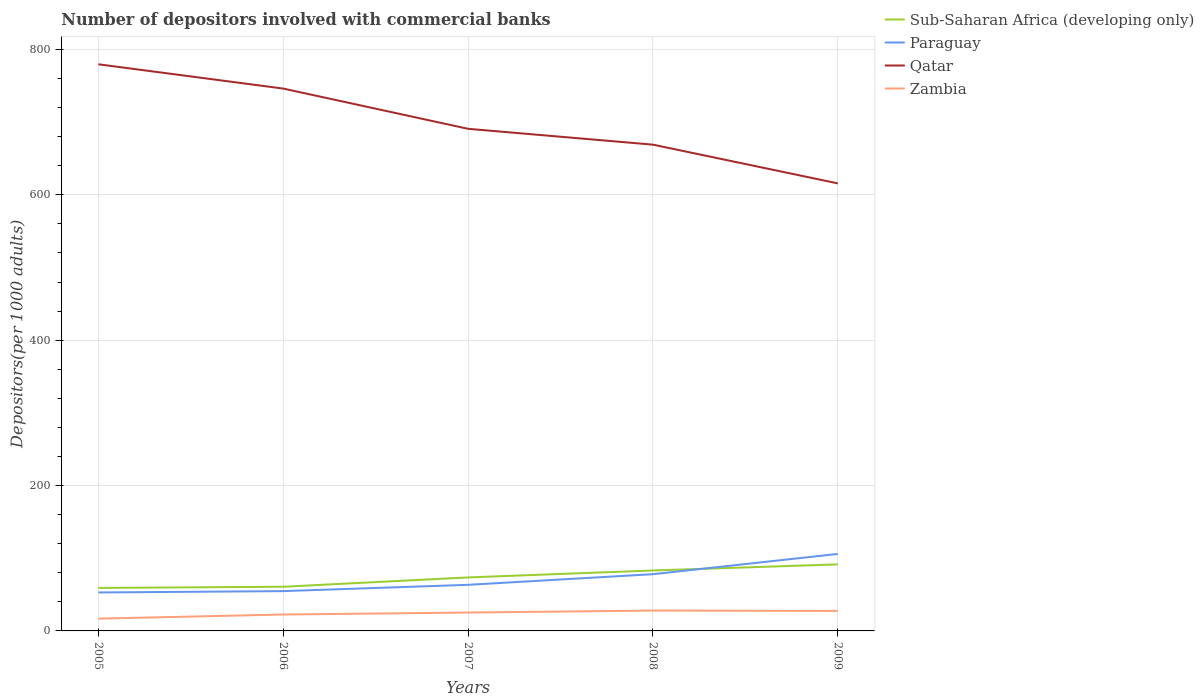How many different coloured lines are there?
Provide a short and direct response. 4. Does the line corresponding to Paraguay intersect with the line corresponding to Sub-Saharan Africa (developing only)?
Provide a succinct answer. Yes. Is the number of lines equal to the number of legend labels?
Give a very brief answer. Yes. Across all years, what is the maximum number of depositors involved with commercial banks in Zambia?
Your answer should be very brief. 16.89. What is the total number of depositors involved with commercial banks in Sub-Saharan Africa (developing only) in the graph?
Offer a very short reply. -32.38. What is the difference between the highest and the second highest number of depositors involved with commercial banks in Sub-Saharan Africa (developing only)?
Your response must be concise. 32.38. How many years are there in the graph?
Your answer should be compact. 5. What is the difference between two consecutive major ticks on the Y-axis?
Provide a succinct answer. 200. Are the values on the major ticks of Y-axis written in scientific E-notation?
Provide a succinct answer. No. Does the graph contain grids?
Your answer should be very brief. Yes. Where does the legend appear in the graph?
Your response must be concise. Top right. How are the legend labels stacked?
Your answer should be compact. Vertical. What is the title of the graph?
Make the answer very short. Number of depositors involved with commercial banks. Does "Antigua and Barbuda" appear as one of the legend labels in the graph?
Give a very brief answer. No. What is the label or title of the Y-axis?
Your answer should be very brief. Depositors(per 1000 adults). What is the Depositors(per 1000 adults) in Sub-Saharan Africa (developing only) in 2005?
Your response must be concise. 59.17. What is the Depositors(per 1000 adults) of Paraguay in 2005?
Make the answer very short. 52.9. What is the Depositors(per 1000 adults) in Qatar in 2005?
Make the answer very short. 779.56. What is the Depositors(per 1000 adults) of Zambia in 2005?
Provide a short and direct response. 16.89. What is the Depositors(per 1000 adults) in Sub-Saharan Africa (developing only) in 2006?
Provide a succinct answer. 60.76. What is the Depositors(per 1000 adults) of Paraguay in 2006?
Provide a short and direct response. 54.74. What is the Depositors(per 1000 adults) in Qatar in 2006?
Make the answer very short. 746.16. What is the Depositors(per 1000 adults) in Zambia in 2006?
Your answer should be very brief. 22.58. What is the Depositors(per 1000 adults) in Sub-Saharan Africa (developing only) in 2007?
Ensure brevity in your answer.  73.6. What is the Depositors(per 1000 adults) of Paraguay in 2007?
Offer a very short reply. 63.43. What is the Depositors(per 1000 adults) of Qatar in 2007?
Your response must be concise. 690.79. What is the Depositors(per 1000 adults) of Zambia in 2007?
Keep it short and to the point. 25.28. What is the Depositors(per 1000 adults) in Sub-Saharan Africa (developing only) in 2008?
Your response must be concise. 83.18. What is the Depositors(per 1000 adults) in Paraguay in 2008?
Keep it short and to the point. 78.05. What is the Depositors(per 1000 adults) of Qatar in 2008?
Offer a very short reply. 668.99. What is the Depositors(per 1000 adults) in Zambia in 2008?
Make the answer very short. 28.01. What is the Depositors(per 1000 adults) in Sub-Saharan Africa (developing only) in 2009?
Give a very brief answer. 91.54. What is the Depositors(per 1000 adults) of Paraguay in 2009?
Offer a terse response. 105.92. What is the Depositors(per 1000 adults) in Qatar in 2009?
Provide a succinct answer. 615.73. What is the Depositors(per 1000 adults) in Zambia in 2009?
Provide a succinct answer. 27.51. Across all years, what is the maximum Depositors(per 1000 adults) in Sub-Saharan Africa (developing only)?
Offer a terse response. 91.54. Across all years, what is the maximum Depositors(per 1000 adults) in Paraguay?
Provide a succinct answer. 105.92. Across all years, what is the maximum Depositors(per 1000 adults) in Qatar?
Keep it short and to the point. 779.56. Across all years, what is the maximum Depositors(per 1000 adults) in Zambia?
Give a very brief answer. 28.01. Across all years, what is the minimum Depositors(per 1000 adults) in Sub-Saharan Africa (developing only)?
Give a very brief answer. 59.17. Across all years, what is the minimum Depositors(per 1000 adults) in Paraguay?
Your answer should be very brief. 52.9. Across all years, what is the minimum Depositors(per 1000 adults) in Qatar?
Make the answer very short. 615.73. Across all years, what is the minimum Depositors(per 1000 adults) of Zambia?
Offer a terse response. 16.89. What is the total Depositors(per 1000 adults) of Sub-Saharan Africa (developing only) in the graph?
Provide a succinct answer. 368.25. What is the total Depositors(per 1000 adults) in Paraguay in the graph?
Your answer should be very brief. 355.04. What is the total Depositors(per 1000 adults) in Qatar in the graph?
Keep it short and to the point. 3501.23. What is the total Depositors(per 1000 adults) of Zambia in the graph?
Give a very brief answer. 120.26. What is the difference between the Depositors(per 1000 adults) of Sub-Saharan Africa (developing only) in 2005 and that in 2006?
Provide a succinct answer. -1.59. What is the difference between the Depositors(per 1000 adults) in Paraguay in 2005 and that in 2006?
Your answer should be compact. -1.85. What is the difference between the Depositors(per 1000 adults) of Qatar in 2005 and that in 2006?
Keep it short and to the point. 33.4. What is the difference between the Depositors(per 1000 adults) in Zambia in 2005 and that in 2006?
Provide a short and direct response. -5.68. What is the difference between the Depositors(per 1000 adults) in Sub-Saharan Africa (developing only) in 2005 and that in 2007?
Keep it short and to the point. -14.43. What is the difference between the Depositors(per 1000 adults) of Paraguay in 2005 and that in 2007?
Offer a terse response. -10.54. What is the difference between the Depositors(per 1000 adults) in Qatar in 2005 and that in 2007?
Your answer should be compact. 88.76. What is the difference between the Depositors(per 1000 adults) of Zambia in 2005 and that in 2007?
Your answer should be compact. -8.38. What is the difference between the Depositors(per 1000 adults) in Sub-Saharan Africa (developing only) in 2005 and that in 2008?
Provide a short and direct response. -24.01. What is the difference between the Depositors(per 1000 adults) of Paraguay in 2005 and that in 2008?
Provide a short and direct response. -25.15. What is the difference between the Depositors(per 1000 adults) in Qatar in 2005 and that in 2008?
Offer a terse response. 110.57. What is the difference between the Depositors(per 1000 adults) of Zambia in 2005 and that in 2008?
Make the answer very short. -11.11. What is the difference between the Depositors(per 1000 adults) in Sub-Saharan Africa (developing only) in 2005 and that in 2009?
Keep it short and to the point. -32.38. What is the difference between the Depositors(per 1000 adults) in Paraguay in 2005 and that in 2009?
Your answer should be very brief. -53.02. What is the difference between the Depositors(per 1000 adults) in Qatar in 2005 and that in 2009?
Provide a succinct answer. 163.83. What is the difference between the Depositors(per 1000 adults) of Zambia in 2005 and that in 2009?
Offer a terse response. -10.61. What is the difference between the Depositors(per 1000 adults) in Sub-Saharan Africa (developing only) in 2006 and that in 2007?
Your answer should be compact. -12.83. What is the difference between the Depositors(per 1000 adults) in Paraguay in 2006 and that in 2007?
Make the answer very short. -8.69. What is the difference between the Depositors(per 1000 adults) in Qatar in 2006 and that in 2007?
Ensure brevity in your answer.  55.37. What is the difference between the Depositors(per 1000 adults) in Zambia in 2006 and that in 2007?
Provide a succinct answer. -2.7. What is the difference between the Depositors(per 1000 adults) of Sub-Saharan Africa (developing only) in 2006 and that in 2008?
Provide a succinct answer. -22.41. What is the difference between the Depositors(per 1000 adults) of Paraguay in 2006 and that in 2008?
Keep it short and to the point. -23.31. What is the difference between the Depositors(per 1000 adults) of Qatar in 2006 and that in 2008?
Your answer should be compact. 77.17. What is the difference between the Depositors(per 1000 adults) of Zambia in 2006 and that in 2008?
Your answer should be compact. -5.43. What is the difference between the Depositors(per 1000 adults) in Sub-Saharan Africa (developing only) in 2006 and that in 2009?
Provide a succinct answer. -30.78. What is the difference between the Depositors(per 1000 adults) of Paraguay in 2006 and that in 2009?
Your response must be concise. -51.17. What is the difference between the Depositors(per 1000 adults) in Qatar in 2006 and that in 2009?
Provide a succinct answer. 130.43. What is the difference between the Depositors(per 1000 adults) of Zambia in 2006 and that in 2009?
Your answer should be very brief. -4.93. What is the difference between the Depositors(per 1000 adults) of Sub-Saharan Africa (developing only) in 2007 and that in 2008?
Provide a short and direct response. -9.58. What is the difference between the Depositors(per 1000 adults) in Paraguay in 2007 and that in 2008?
Provide a short and direct response. -14.62. What is the difference between the Depositors(per 1000 adults) in Qatar in 2007 and that in 2008?
Ensure brevity in your answer.  21.8. What is the difference between the Depositors(per 1000 adults) of Zambia in 2007 and that in 2008?
Give a very brief answer. -2.73. What is the difference between the Depositors(per 1000 adults) of Sub-Saharan Africa (developing only) in 2007 and that in 2009?
Give a very brief answer. -17.95. What is the difference between the Depositors(per 1000 adults) of Paraguay in 2007 and that in 2009?
Your response must be concise. -42.48. What is the difference between the Depositors(per 1000 adults) in Qatar in 2007 and that in 2009?
Provide a short and direct response. 75.07. What is the difference between the Depositors(per 1000 adults) of Zambia in 2007 and that in 2009?
Offer a very short reply. -2.23. What is the difference between the Depositors(per 1000 adults) in Sub-Saharan Africa (developing only) in 2008 and that in 2009?
Offer a terse response. -8.37. What is the difference between the Depositors(per 1000 adults) of Paraguay in 2008 and that in 2009?
Provide a short and direct response. -27.87. What is the difference between the Depositors(per 1000 adults) of Qatar in 2008 and that in 2009?
Ensure brevity in your answer.  53.27. What is the difference between the Depositors(per 1000 adults) in Zambia in 2008 and that in 2009?
Provide a short and direct response. 0.5. What is the difference between the Depositors(per 1000 adults) of Sub-Saharan Africa (developing only) in 2005 and the Depositors(per 1000 adults) of Paraguay in 2006?
Ensure brevity in your answer.  4.42. What is the difference between the Depositors(per 1000 adults) in Sub-Saharan Africa (developing only) in 2005 and the Depositors(per 1000 adults) in Qatar in 2006?
Offer a terse response. -686.99. What is the difference between the Depositors(per 1000 adults) in Sub-Saharan Africa (developing only) in 2005 and the Depositors(per 1000 adults) in Zambia in 2006?
Ensure brevity in your answer.  36.59. What is the difference between the Depositors(per 1000 adults) of Paraguay in 2005 and the Depositors(per 1000 adults) of Qatar in 2006?
Your answer should be very brief. -693.26. What is the difference between the Depositors(per 1000 adults) in Paraguay in 2005 and the Depositors(per 1000 adults) in Zambia in 2006?
Provide a short and direct response. 30.32. What is the difference between the Depositors(per 1000 adults) of Qatar in 2005 and the Depositors(per 1000 adults) of Zambia in 2006?
Offer a terse response. 756.98. What is the difference between the Depositors(per 1000 adults) in Sub-Saharan Africa (developing only) in 2005 and the Depositors(per 1000 adults) in Paraguay in 2007?
Make the answer very short. -4.27. What is the difference between the Depositors(per 1000 adults) in Sub-Saharan Africa (developing only) in 2005 and the Depositors(per 1000 adults) in Qatar in 2007?
Offer a very short reply. -631.63. What is the difference between the Depositors(per 1000 adults) in Sub-Saharan Africa (developing only) in 2005 and the Depositors(per 1000 adults) in Zambia in 2007?
Your answer should be very brief. 33.89. What is the difference between the Depositors(per 1000 adults) of Paraguay in 2005 and the Depositors(per 1000 adults) of Qatar in 2007?
Your response must be concise. -637.9. What is the difference between the Depositors(per 1000 adults) in Paraguay in 2005 and the Depositors(per 1000 adults) in Zambia in 2007?
Ensure brevity in your answer.  27.62. What is the difference between the Depositors(per 1000 adults) in Qatar in 2005 and the Depositors(per 1000 adults) in Zambia in 2007?
Give a very brief answer. 754.28. What is the difference between the Depositors(per 1000 adults) of Sub-Saharan Africa (developing only) in 2005 and the Depositors(per 1000 adults) of Paraguay in 2008?
Make the answer very short. -18.88. What is the difference between the Depositors(per 1000 adults) of Sub-Saharan Africa (developing only) in 2005 and the Depositors(per 1000 adults) of Qatar in 2008?
Provide a succinct answer. -609.82. What is the difference between the Depositors(per 1000 adults) of Sub-Saharan Africa (developing only) in 2005 and the Depositors(per 1000 adults) of Zambia in 2008?
Offer a terse response. 31.16. What is the difference between the Depositors(per 1000 adults) in Paraguay in 2005 and the Depositors(per 1000 adults) in Qatar in 2008?
Ensure brevity in your answer.  -616.1. What is the difference between the Depositors(per 1000 adults) in Paraguay in 2005 and the Depositors(per 1000 adults) in Zambia in 2008?
Your answer should be compact. 24.89. What is the difference between the Depositors(per 1000 adults) in Qatar in 2005 and the Depositors(per 1000 adults) in Zambia in 2008?
Provide a succinct answer. 751.55. What is the difference between the Depositors(per 1000 adults) of Sub-Saharan Africa (developing only) in 2005 and the Depositors(per 1000 adults) of Paraguay in 2009?
Give a very brief answer. -46.75. What is the difference between the Depositors(per 1000 adults) in Sub-Saharan Africa (developing only) in 2005 and the Depositors(per 1000 adults) in Qatar in 2009?
Provide a short and direct response. -556.56. What is the difference between the Depositors(per 1000 adults) in Sub-Saharan Africa (developing only) in 2005 and the Depositors(per 1000 adults) in Zambia in 2009?
Offer a terse response. 31.66. What is the difference between the Depositors(per 1000 adults) of Paraguay in 2005 and the Depositors(per 1000 adults) of Qatar in 2009?
Ensure brevity in your answer.  -562.83. What is the difference between the Depositors(per 1000 adults) of Paraguay in 2005 and the Depositors(per 1000 adults) of Zambia in 2009?
Provide a succinct answer. 25.39. What is the difference between the Depositors(per 1000 adults) of Qatar in 2005 and the Depositors(per 1000 adults) of Zambia in 2009?
Make the answer very short. 752.05. What is the difference between the Depositors(per 1000 adults) of Sub-Saharan Africa (developing only) in 2006 and the Depositors(per 1000 adults) of Paraguay in 2007?
Your response must be concise. -2.67. What is the difference between the Depositors(per 1000 adults) in Sub-Saharan Africa (developing only) in 2006 and the Depositors(per 1000 adults) in Qatar in 2007?
Offer a terse response. -630.03. What is the difference between the Depositors(per 1000 adults) in Sub-Saharan Africa (developing only) in 2006 and the Depositors(per 1000 adults) in Zambia in 2007?
Offer a very short reply. 35.49. What is the difference between the Depositors(per 1000 adults) in Paraguay in 2006 and the Depositors(per 1000 adults) in Qatar in 2007?
Provide a short and direct response. -636.05. What is the difference between the Depositors(per 1000 adults) in Paraguay in 2006 and the Depositors(per 1000 adults) in Zambia in 2007?
Make the answer very short. 29.47. What is the difference between the Depositors(per 1000 adults) of Qatar in 2006 and the Depositors(per 1000 adults) of Zambia in 2007?
Make the answer very short. 720.88. What is the difference between the Depositors(per 1000 adults) of Sub-Saharan Africa (developing only) in 2006 and the Depositors(per 1000 adults) of Paraguay in 2008?
Provide a succinct answer. -17.29. What is the difference between the Depositors(per 1000 adults) of Sub-Saharan Africa (developing only) in 2006 and the Depositors(per 1000 adults) of Qatar in 2008?
Offer a terse response. -608.23. What is the difference between the Depositors(per 1000 adults) in Sub-Saharan Africa (developing only) in 2006 and the Depositors(per 1000 adults) in Zambia in 2008?
Make the answer very short. 32.76. What is the difference between the Depositors(per 1000 adults) in Paraguay in 2006 and the Depositors(per 1000 adults) in Qatar in 2008?
Your answer should be compact. -614.25. What is the difference between the Depositors(per 1000 adults) of Paraguay in 2006 and the Depositors(per 1000 adults) of Zambia in 2008?
Offer a terse response. 26.74. What is the difference between the Depositors(per 1000 adults) in Qatar in 2006 and the Depositors(per 1000 adults) in Zambia in 2008?
Ensure brevity in your answer.  718.16. What is the difference between the Depositors(per 1000 adults) in Sub-Saharan Africa (developing only) in 2006 and the Depositors(per 1000 adults) in Paraguay in 2009?
Give a very brief answer. -45.15. What is the difference between the Depositors(per 1000 adults) of Sub-Saharan Africa (developing only) in 2006 and the Depositors(per 1000 adults) of Qatar in 2009?
Offer a very short reply. -554.96. What is the difference between the Depositors(per 1000 adults) of Sub-Saharan Africa (developing only) in 2006 and the Depositors(per 1000 adults) of Zambia in 2009?
Keep it short and to the point. 33.25. What is the difference between the Depositors(per 1000 adults) of Paraguay in 2006 and the Depositors(per 1000 adults) of Qatar in 2009?
Offer a terse response. -560.98. What is the difference between the Depositors(per 1000 adults) in Paraguay in 2006 and the Depositors(per 1000 adults) in Zambia in 2009?
Your answer should be very brief. 27.24. What is the difference between the Depositors(per 1000 adults) in Qatar in 2006 and the Depositors(per 1000 adults) in Zambia in 2009?
Provide a succinct answer. 718.65. What is the difference between the Depositors(per 1000 adults) in Sub-Saharan Africa (developing only) in 2007 and the Depositors(per 1000 adults) in Paraguay in 2008?
Provide a short and direct response. -4.45. What is the difference between the Depositors(per 1000 adults) of Sub-Saharan Africa (developing only) in 2007 and the Depositors(per 1000 adults) of Qatar in 2008?
Ensure brevity in your answer.  -595.39. What is the difference between the Depositors(per 1000 adults) in Sub-Saharan Africa (developing only) in 2007 and the Depositors(per 1000 adults) in Zambia in 2008?
Your answer should be compact. 45.59. What is the difference between the Depositors(per 1000 adults) of Paraguay in 2007 and the Depositors(per 1000 adults) of Qatar in 2008?
Offer a terse response. -605.56. What is the difference between the Depositors(per 1000 adults) in Paraguay in 2007 and the Depositors(per 1000 adults) in Zambia in 2008?
Provide a short and direct response. 35.43. What is the difference between the Depositors(per 1000 adults) in Qatar in 2007 and the Depositors(per 1000 adults) in Zambia in 2008?
Offer a terse response. 662.79. What is the difference between the Depositors(per 1000 adults) of Sub-Saharan Africa (developing only) in 2007 and the Depositors(per 1000 adults) of Paraguay in 2009?
Your answer should be compact. -32.32. What is the difference between the Depositors(per 1000 adults) of Sub-Saharan Africa (developing only) in 2007 and the Depositors(per 1000 adults) of Qatar in 2009?
Offer a very short reply. -542.13. What is the difference between the Depositors(per 1000 adults) of Sub-Saharan Africa (developing only) in 2007 and the Depositors(per 1000 adults) of Zambia in 2009?
Keep it short and to the point. 46.09. What is the difference between the Depositors(per 1000 adults) in Paraguay in 2007 and the Depositors(per 1000 adults) in Qatar in 2009?
Your answer should be compact. -552.29. What is the difference between the Depositors(per 1000 adults) in Paraguay in 2007 and the Depositors(per 1000 adults) in Zambia in 2009?
Offer a very short reply. 35.93. What is the difference between the Depositors(per 1000 adults) in Qatar in 2007 and the Depositors(per 1000 adults) in Zambia in 2009?
Ensure brevity in your answer.  663.29. What is the difference between the Depositors(per 1000 adults) of Sub-Saharan Africa (developing only) in 2008 and the Depositors(per 1000 adults) of Paraguay in 2009?
Keep it short and to the point. -22.74. What is the difference between the Depositors(per 1000 adults) in Sub-Saharan Africa (developing only) in 2008 and the Depositors(per 1000 adults) in Qatar in 2009?
Provide a succinct answer. -532.55. What is the difference between the Depositors(per 1000 adults) of Sub-Saharan Africa (developing only) in 2008 and the Depositors(per 1000 adults) of Zambia in 2009?
Your answer should be very brief. 55.67. What is the difference between the Depositors(per 1000 adults) in Paraguay in 2008 and the Depositors(per 1000 adults) in Qatar in 2009?
Provide a succinct answer. -537.68. What is the difference between the Depositors(per 1000 adults) in Paraguay in 2008 and the Depositors(per 1000 adults) in Zambia in 2009?
Provide a short and direct response. 50.54. What is the difference between the Depositors(per 1000 adults) in Qatar in 2008 and the Depositors(per 1000 adults) in Zambia in 2009?
Keep it short and to the point. 641.48. What is the average Depositors(per 1000 adults) in Sub-Saharan Africa (developing only) per year?
Your response must be concise. 73.65. What is the average Depositors(per 1000 adults) in Paraguay per year?
Offer a very short reply. 71.01. What is the average Depositors(per 1000 adults) in Qatar per year?
Provide a succinct answer. 700.25. What is the average Depositors(per 1000 adults) of Zambia per year?
Ensure brevity in your answer.  24.05. In the year 2005, what is the difference between the Depositors(per 1000 adults) in Sub-Saharan Africa (developing only) and Depositors(per 1000 adults) in Paraguay?
Your answer should be very brief. 6.27. In the year 2005, what is the difference between the Depositors(per 1000 adults) in Sub-Saharan Africa (developing only) and Depositors(per 1000 adults) in Qatar?
Provide a short and direct response. -720.39. In the year 2005, what is the difference between the Depositors(per 1000 adults) of Sub-Saharan Africa (developing only) and Depositors(per 1000 adults) of Zambia?
Your answer should be compact. 42.27. In the year 2005, what is the difference between the Depositors(per 1000 adults) of Paraguay and Depositors(per 1000 adults) of Qatar?
Offer a very short reply. -726.66. In the year 2005, what is the difference between the Depositors(per 1000 adults) in Paraguay and Depositors(per 1000 adults) in Zambia?
Make the answer very short. 36. In the year 2005, what is the difference between the Depositors(per 1000 adults) of Qatar and Depositors(per 1000 adults) of Zambia?
Your answer should be very brief. 762.66. In the year 2006, what is the difference between the Depositors(per 1000 adults) of Sub-Saharan Africa (developing only) and Depositors(per 1000 adults) of Paraguay?
Provide a short and direct response. 6.02. In the year 2006, what is the difference between the Depositors(per 1000 adults) of Sub-Saharan Africa (developing only) and Depositors(per 1000 adults) of Qatar?
Ensure brevity in your answer.  -685.4. In the year 2006, what is the difference between the Depositors(per 1000 adults) of Sub-Saharan Africa (developing only) and Depositors(per 1000 adults) of Zambia?
Provide a succinct answer. 38.18. In the year 2006, what is the difference between the Depositors(per 1000 adults) of Paraguay and Depositors(per 1000 adults) of Qatar?
Ensure brevity in your answer.  -691.42. In the year 2006, what is the difference between the Depositors(per 1000 adults) of Paraguay and Depositors(per 1000 adults) of Zambia?
Ensure brevity in your answer.  32.17. In the year 2006, what is the difference between the Depositors(per 1000 adults) of Qatar and Depositors(per 1000 adults) of Zambia?
Offer a terse response. 723.58. In the year 2007, what is the difference between the Depositors(per 1000 adults) in Sub-Saharan Africa (developing only) and Depositors(per 1000 adults) in Paraguay?
Your answer should be compact. 10.16. In the year 2007, what is the difference between the Depositors(per 1000 adults) in Sub-Saharan Africa (developing only) and Depositors(per 1000 adults) in Qatar?
Ensure brevity in your answer.  -617.2. In the year 2007, what is the difference between the Depositors(per 1000 adults) in Sub-Saharan Africa (developing only) and Depositors(per 1000 adults) in Zambia?
Give a very brief answer. 48.32. In the year 2007, what is the difference between the Depositors(per 1000 adults) in Paraguay and Depositors(per 1000 adults) in Qatar?
Provide a succinct answer. -627.36. In the year 2007, what is the difference between the Depositors(per 1000 adults) in Paraguay and Depositors(per 1000 adults) in Zambia?
Your answer should be compact. 38.16. In the year 2007, what is the difference between the Depositors(per 1000 adults) in Qatar and Depositors(per 1000 adults) in Zambia?
Offer a terse response. 665.52. In the year 2008, what is the difference between the Depositors(per 1000 adults) of Sub-Saharan Africa (developing only) and Depositors(per 1000 adults) of Paraguay?
Offer a very short reply. 5.13. In the year 2008, what is the difference between the Depositors(per 1000 adults) in Sub-Saharan Africa (developing only) and Depositors(per 1000 adults) in Qatar?
Your answer should be compact. -585.81. In the year 2008, what is the difference between the Depositors(per 1000 adults) in Sub-Saharan Africa (developing only) and Depositors(per 1000 adults) in Zambia?
Ensure brevity in your answer.  55.17. In the year 2008, what is the difference between the Depositors(per 1000 adults) of Paraguay and Depositors(per 1000 adults) of Qatar?
Give a very brief answer. -590.94. In the year 2008, what is the difference between the Depositors(per 1000 adults) in Paraguay and Depositors(per 1000 adults) in Zambia?
Give a very brief answer. 50.05. In the year 2008, what is the difference between the Depositors(per 1000 adults) in Qatar and Depositors(per 1000 adults) in Zambia?
Your answer should be compact. 640.99. In the year 2009, what is the difference between the Depositors(per 1000 adults) of Sub-Saharan Africa (developing only) and Depositors(per 1000 adults) of Paraguay?
Offer a terse response. -14.37. In the year 2009, what is the difference between the Depositors(per 1000 adults) of Sub-Saharan Africa (developing only) and Depositors(per 1000 adults) of Qatar?
Provide a succinct answer. -524.18. In the year 2009, what is the difference between the Depositors(per 1000 adults) of Sub-Saharan Africa (developing only) and Depositors(per 1000 adults) of Zambia?
Your answer should be compact. 64.03. In the year 2009, what is the difference between the Depositors(per 1000 adults) in Paraguay and Depositors(per 1000 adults) in Qatar?
Offer a terse response. -509.81. In the year 2009, what is the difference between the Depositors(per 1000 adults) in Paraguay and Depositors(per 1000 adults) in Zambia?
Your answer should be compact. 78.41. In the year 2009, what is the difference between the Depositors(per 1000 adults) in Qatar and Depositors(per 1000 adults) in Zambia?
Your answer should be very brief. 588.22. What is the ratio of the Depositors(per 1000 adults) in Sub-Saharan Africa (developing only) in 2005 to that in 2006?
Your response must be concise. 0.97. What is the ratio of the Depositors(per 1000 adults) in Paraguay in 2005 to that in 2006?
Give a very brief answer. 0.97. What is the ratio of the Depositors(per 1000 adults) in Qatar in 2005 to that in 2006?
Your answer should be compact. 1.04. What is the ratio of the Depositors(per 1000 adults) in Zambia in 2005 to that in 2006?
Ensure brevity in your answer.  0.75. What is the ratio of the Depositors(per 1000 adults) in Sub-Saharan Africa (developing only) in 2005 to that in 2007?
Your response must be concise. 0.8. What is the ratio of the Depositors(per 1000 adults) of Paraguay in 2005 to that in 2007?
Ensure brevity in your answer.  0.83. What is the ratio of the Depositors(per 1000 adults) in Qatar in 2005 to that in 2007?
Provide a short and direct response. 1.13. What is the ratio of the Depositors(per 1000 adults) of Zambia in 2005 to that in 2007?
Provide a succinct answer. 0.67. What is the ratio of the Depositors(per 1000 adults) of Sub-Saharan Africa (developing only) in 2005 to that in 2008?
Provide a short and direct response. 0.71. What is the ratio of the Depositors(per 1000 adults) of Paraguay in 2005 to that in 2008?
Keep it short and to the point. 0.68. What is the ratio of the Depositors(per 1000 adults) of Qatar in 2005 to that in 2008?
Your response must be concise. 1.17. What is the ratio of the Depositors(per 1000 adults) of Zambia in 2005 to that in 2008?
Your response must be concise. 0.6. What is the ratio of the Depositors(per 1000 adults) in Sub-Saharan Africa (developing only) in 2005 to that in 2009?
Offer a terse response. 0.65. What is the ratio of the Depositors(per 1000 adults) of Paraguay in 2005 to that in 2009?
Provide a succinct answer. 0.5. What is the ratio of the Depositors(per 1000 adults) of Qatar in 2005 to that in 2009?
Provide a short and direct response. 1.27. What is the ratio of the Depositors(per 1000 adults) of Zambia in 2005 to that in 2009?
Your response must be concise. 0.61. What is the ratio of the Depositors(per 1000 adults) in Sub-Saharan Africa (developing only) in 2006 to that in 2007?
Your response must be concise. 0.83. What is the ratio of the Depositors(per 1000 adults) of Paraguay in 2006 to that in 2007?
Make the answer very short. 0.86. What is the ratio of the Depositors(per 1000 adults) of Qatar in 2006 to that in 2007?
Your response must be concise. 1.08. What is the ratio of the Depositors(per 1000 adults) of Zambia in 2006 to that in 2007?
Offer a terse response. 0.89. What is the ratio of the Depositors(per 1000 adults) in Sub-Saharan Africa (developing only) in 2006 to that in 2008?
Your answer should be compact. 0.73. What is the ratio of the Depositors(per 1000 adults) of Paraguay in 2006 to that in 2008?
Offer a very short reply. 0.7. What is the ratio of the Depositors(per 1000 adults) in Qatar in 2006 to that in 2008?
Your response must be concise. 1.12. What is the ratio of the Depositors(per 1000 adults) of Zambia in 2006 to that in 2008?
Keep it short and to the point. 0.81. What is the ratio of the Depositors(per 1000 adults) in Sub-Saharan Africa (developing only) in 2006 to that in 2009?
Your answer should be very brief. 0.66. What is the ratio of the Depositors(per 1000 adults) in Paraguay in 2006 to that in 2009?
Provide a succinct answer. 0.52. What is the ratio of the Depositors(per 1000 adults) of Qatar in 2006 to that in 2009?
Make the answer very short. 1.21. What is the ratio of the Depositors(per 1000 adults) of Zambia in 2006 to that in 2009?
Offer a terse response. 0.82. What is the ratio of the Depositors(per 1000 adults) of Sub-Saharan Africa (developing only) in 2007 to that in 2008?
Your answer should be very brief. 0.88. What is the ratio of the Depositors(per 1000 adults) in Paraguay in 2007 to that in 2008?
Provide a succinct answer. 0.81. What is the ratio of the Depositors(per 1000 adults) in Qatar in 2007 to that in 2008?
Provide a succinct answer. 1.03. What is the ratio of the Depositors(per 1000 adults) of Zambia in 2007 to that in 2008?
Your response must be concise. 0.9. What is the ratio of the Depositors(per 1000 adults) of Sub-Saharan Africa (developing only) in 2007 to that in 2009?
Provide a short and direct response. 0.8. What is the ratio of the Depositors(per 1000 adults) in Paraguay in 2007 to that in 2009?
Provide a short and direct response. 0.6. What is the ratio of the Depositors(per 1000 adults) in Qatar in 2007 to that in 2009?
Keep it short and to the point. 1.12. What is the ratio of the Depositors(per 1000 adults) of Zambia in 2007 to that in 2009?
Offer a very short reply. 0.92. What is the ratio of the Depositors(per 1000 adults) of Sub-Saharan Africa (developing only) in 2008 to that in 2009?
Ensure brevity in your answer.  0.91. What is the ratio of the Depositors(per 1000 adults) of Paraguay in 2008 to that in 2009?
Provide a short and direct response. 0.74. What is the ratio of the Depositors(per 1000 adults) of Qatar in 2008 to that in 2009?
Your answer should be compact. 1.09. What is the difference between the highest and the second highest Depositors(per 1000 adults) of Sub-Saharan Africa (developing only)?
Offer a very short reply. 8.37. What is the difference between the highest and the second highest Depositors(per 1000 adults) of Paraguay?
Ensure brevity in your answer.  27.87. What is the difference between the highest and the second highest Depositors(per 1000 adults) in Qatar?
Make the answer very short. 33.4. What is the difference between the highest and the second highest Depositors(per 1000 adults) of Zambia?
Your response must be concise. 0.5. What is the difference between the highest and the lowest Depositors(per 1000 adults) of Sub-Saharan Africa (developing only)?
Ensure brevity in your answer.  32.38. What is the difference between the highest and the lowest Depositors(per 1000 adults) in Paraguay?
Your response must be concise. 53.02. What is the difference between the highest and the lowest Depositors(per 1000 adults) of Qatar?
Give a very brief answer. 163.83. What is the difference between the highest and the lowest Depositors(per 1000 adults) of Zambia?
Your response must be concise. 11.11. 